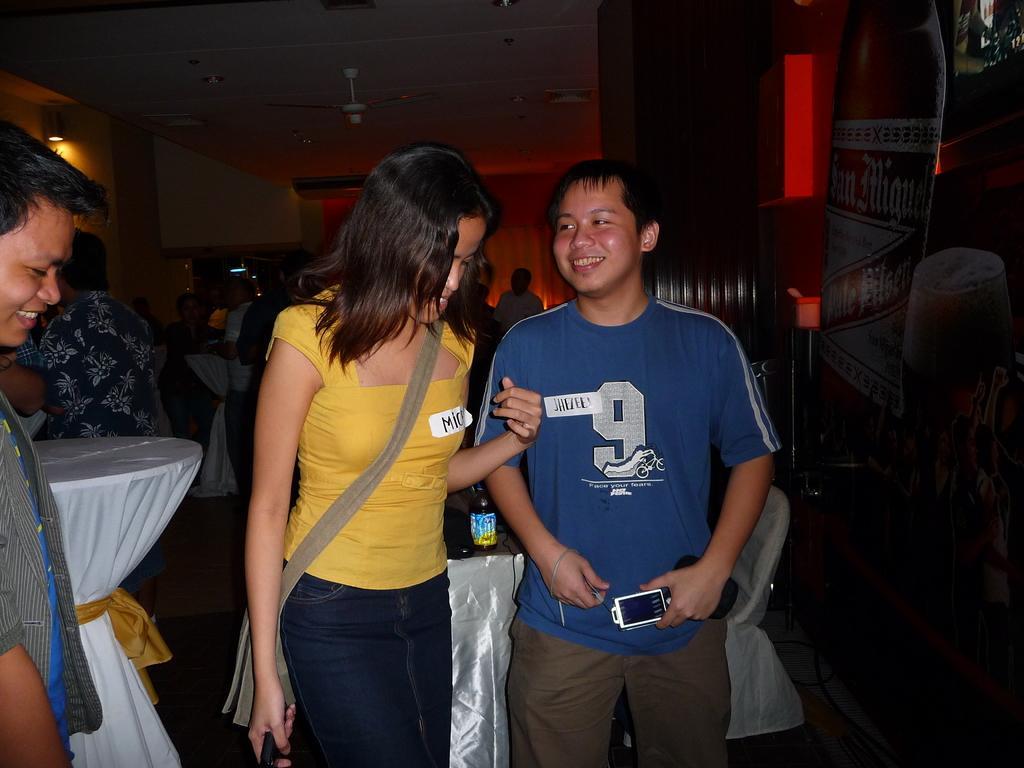How would you summarize this image in a sentence or two? In this image I can see group of people standing. In front the person is wearing blue and brown color dress and the person at left is yellow color shirt. In the background I can see few lights. 